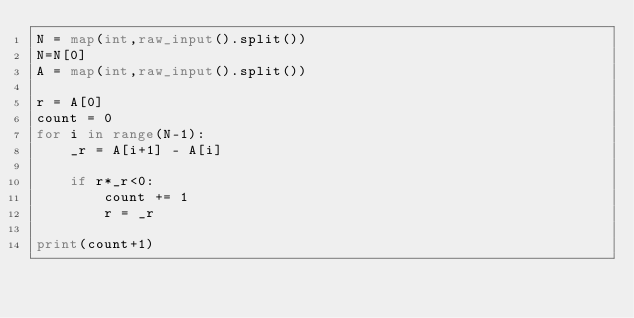Convert code to text. <code><loc_0><loc_0><loc_500><loc_500><_Python_>N = map(int,raw_input().split())
N=N[0]
A = map(int,raw_input().split())

r = A[0]
count = 0
for i in range(N-1):
    _r = A[i+1] - A[i]

    if r*_r<0:
        count += 1
        r = _r
 
print(count+1)
</code> 